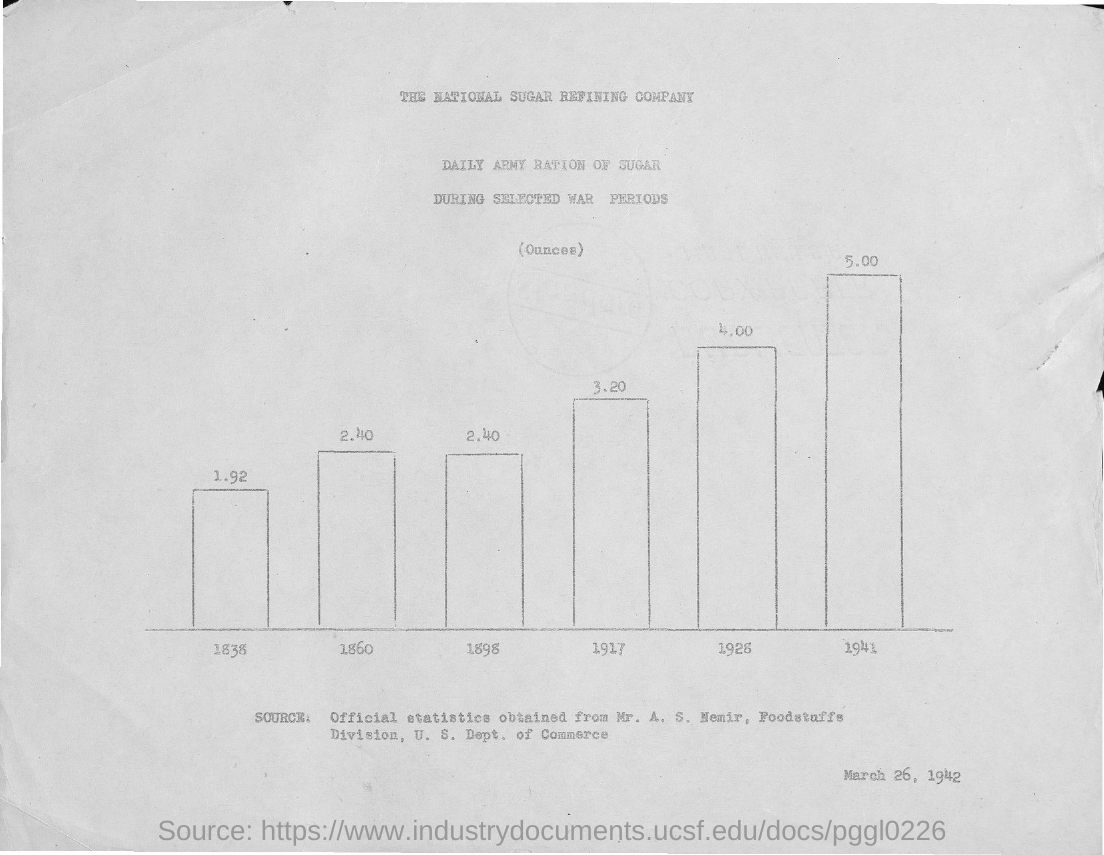What is the date mentioned in the document?
Provide a short and direct response. March 26, 1942. What is the first title in the document?
Offer a terse response. The National Sugar Refining Company. What is the daily army ration in the year 1838?
Provide a short and direct response. 1.92. The daily army ration is higher in which year?
Keep it short and to the point. 1941. The daily army ration is lower in which year?
Your answer should be compact. 1838. 